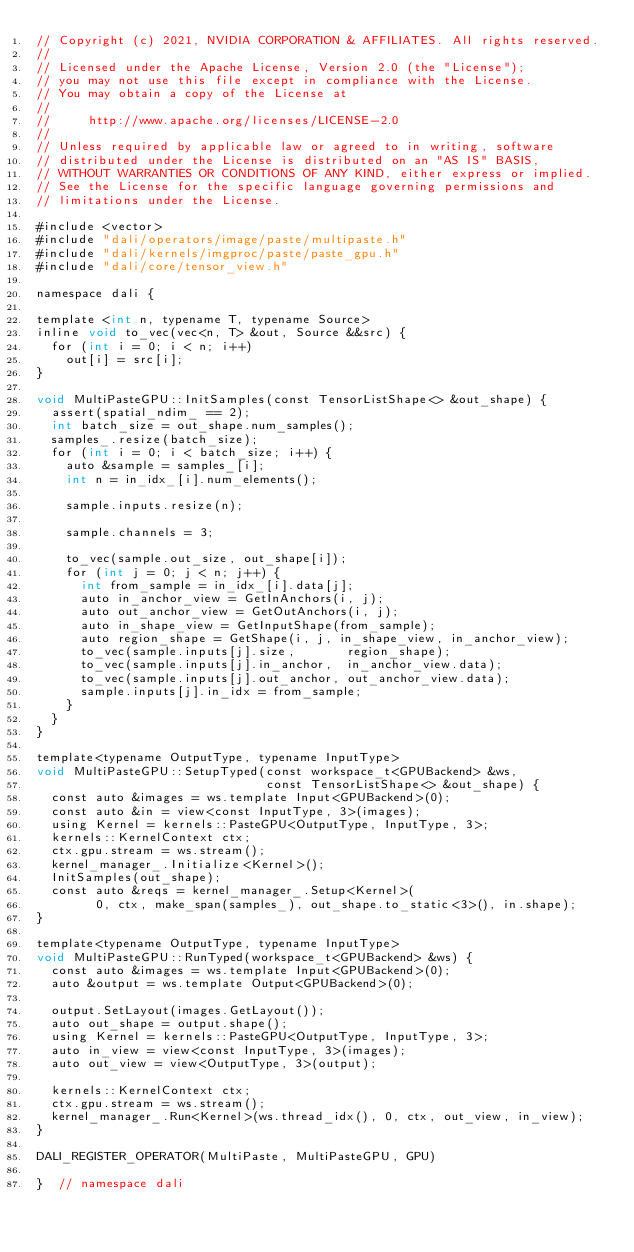Convert code to text. <code><loc_0><loc_0><loc_500><loc_500><_Cuda_>// Copyright (c) 2021, NVIDIA CORPORATION & AFFILIATES. All rights reserved.
//
// Licensed under the Apache License, Version 2.0 (the "License");
// you may not use this file except in compliance with the License.
// You may obtain a copy of the License at
//
//     http://www.apache.org/licenses/LICENSE-2.0
//
// Unless required by applicable law or agreed to in writing, software
// distributed under the License is distributed on an "AS IS" BASIS,
// WITHOUT WARRANTIES OR CONDITIONS OF ANY KIND, either express or implied.
// See the License for the specific language governing permissions and
// limitations under the License.

#include <vector>
#include "dali/operators/image/paste/multipaste.h"
#include "dali/kernels/imgproc/paste/paste_gpu.h"
#include "dali/core/tensor_view.h"

namespace dali {

template <int n, typename T, typename Source>
inline void to_vec(vec<n, T> &out, Source &&src) {
  for (int i = 0; i < n; i++)
    out[i] = src[i];
}

void MultiPasteGPU::InitSamples(const TensorListShape<> &out_shape) {
  assert(spatial_ndim_ == 2);
  int batch_size = out_shape.num_samples();
  samples_.resize(batch_size);
  for (int i = 0; i < batch_size; i++) {
    auto &sample = samples_[i];
    int n = in_idx_[i].num_elements();

    sample.inputs.resize(n);

    sample.channels = 3;

    to_vec(sample.out_size, out_shape[i]);
    for (int j = 0; j < n; j++) {
      int from_sample = in_idx_[i].data[j];
      auto in_anchor_view = GetInAnchors(i, j);
      auto out_anchor_view = GetOutAnchors(i, j);
      auto in_shape_view = GetInputShape(from_sample);
      auto region_shape = GetShape(i, j, in_shape_view, in_anchor_view);
      to_vec(sample.inputs[j].size,       region_shape);
      to_vec(sample.inputs[j].in_anchor,  in_anchor_view.data);
      to_vec(sample.inputs[j].out_anchor, out_anchor_view.data);
      sample.inputs[j].in_idx = from_sample;
    }
  }
}

template<typename OutputType, typename InputType>
void MultiPasteGPU::SetupTyped(const workspace_t<GPUBackend> &ws,
                               const TensorListShape<> &out_shape) {
  const auto &images = ws.template Input<GPUBackend>(0);
  const auto &in = view<const InputType, 3>(images);
  using Kernel = kernels::PasteGPU<OutputType, InputType, 3>;
  kernels::KernelContext ctx;
  ctx.gpu.stream = ws.stream();
  kernel_manager_.Initialize<Kernel>();
  InitSamples(out_shape);
  const auto &reqs = kernel_manager_.Setup<Kernel>(
        0, ctx, make_span(samples_), out_shape.to_static<3>(), in.shape);
}

template<typename OutputType, typename InputType>
void MultiPasteGPU::RunTyped(workspace_t<GPUBackend> &ws) {
  const auto &images = ws.template Input<GPUBackend>(0);
  auto &output = ws.template Output<GPUBackend>(0);

  output.SetLayout(images.GetLayout());
  auto out_shape = output.shape();
  using Kernel = kernels::PasteGPU<OutputType, InputType, 3>;
  auto in_view = view<const InputType, 3>(images);
  auto out_view = view<OutputType, 3>(output);

  kernels::KernelContext ctx;
  ctx.gpu.stream = ws.stream();
  kernel_manager_.Run<Kernel>(ws.thread_idx(), 0, ctx, out_view, in_view);
}

DALI_REGISTER_OPERATOR(MultiPaste, MultiPasteGPU, GPU)

}  // namespace dali
</code> 